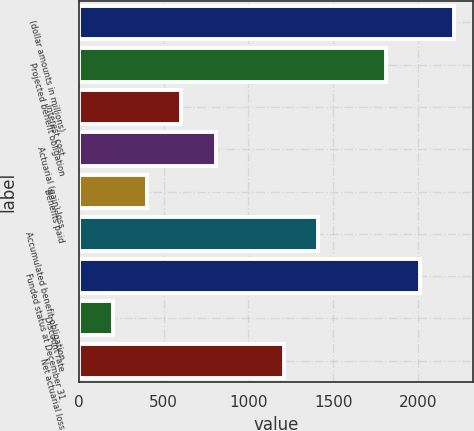Convert chart to OTSL. <chart><loc_0><loc_0><loc_500><loc_500><bar_chart><fcel>(dollar amounts in millions)<fcel>Projected benefit obligation<fcel>Interest cost<fcel>Actuarial (gain) loss<fcel>Benefits paid<fcel>Accumulated benefit obligation<fcel>Funded status at December 31<fcel>Discount rate<fcel>Net actuarial loss<nl><fcel>2213<fcel>1811<fcel>605<fcel>806<fcel>404<fcel>1409<fcel>2012<fcel>203<fcel>1208<nl></chart> 